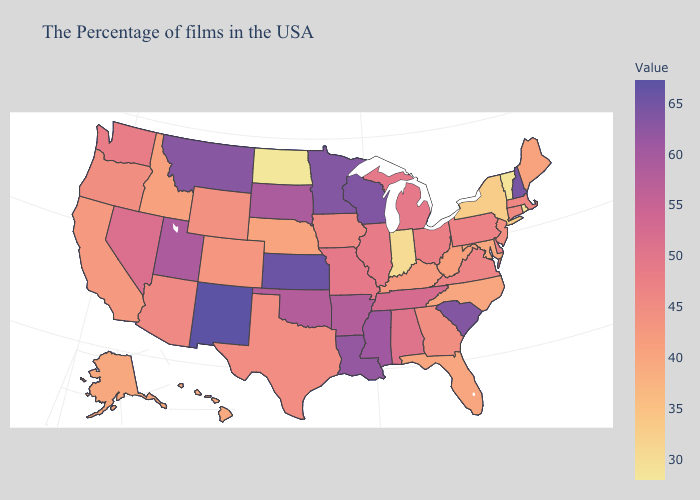Is the legend a continuous bar?
Be succinct. Yes. 